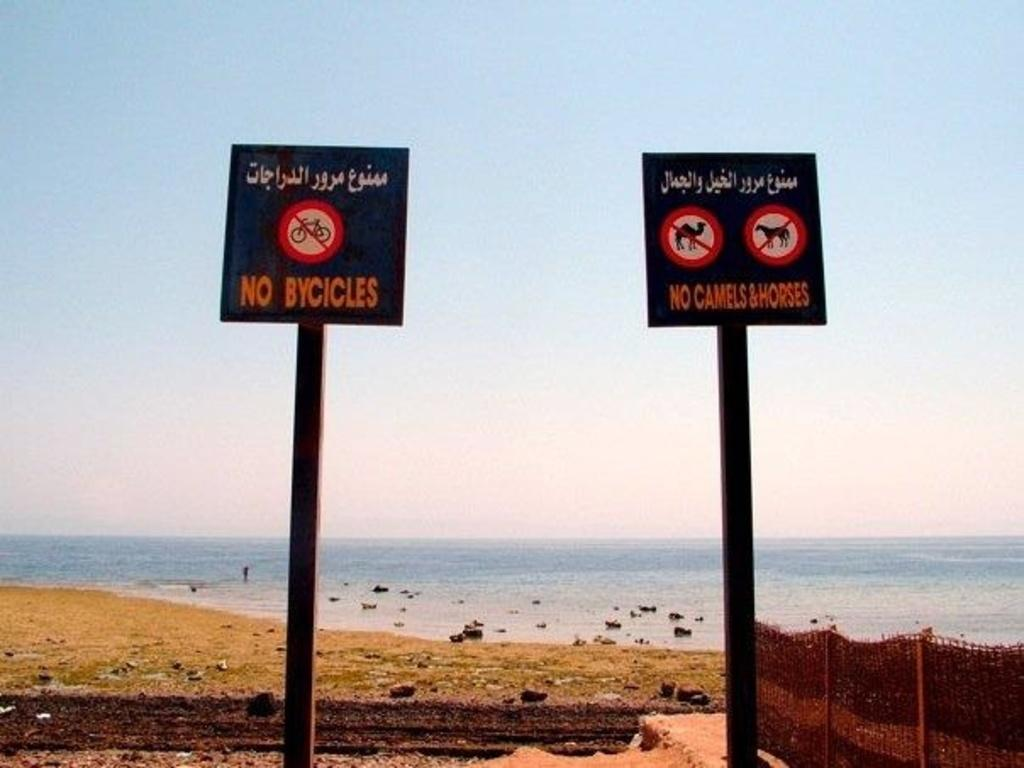<image>
Render a clear and concise summary of the photo. Two signs at a beach that says no bycicles and no camels & horses. 